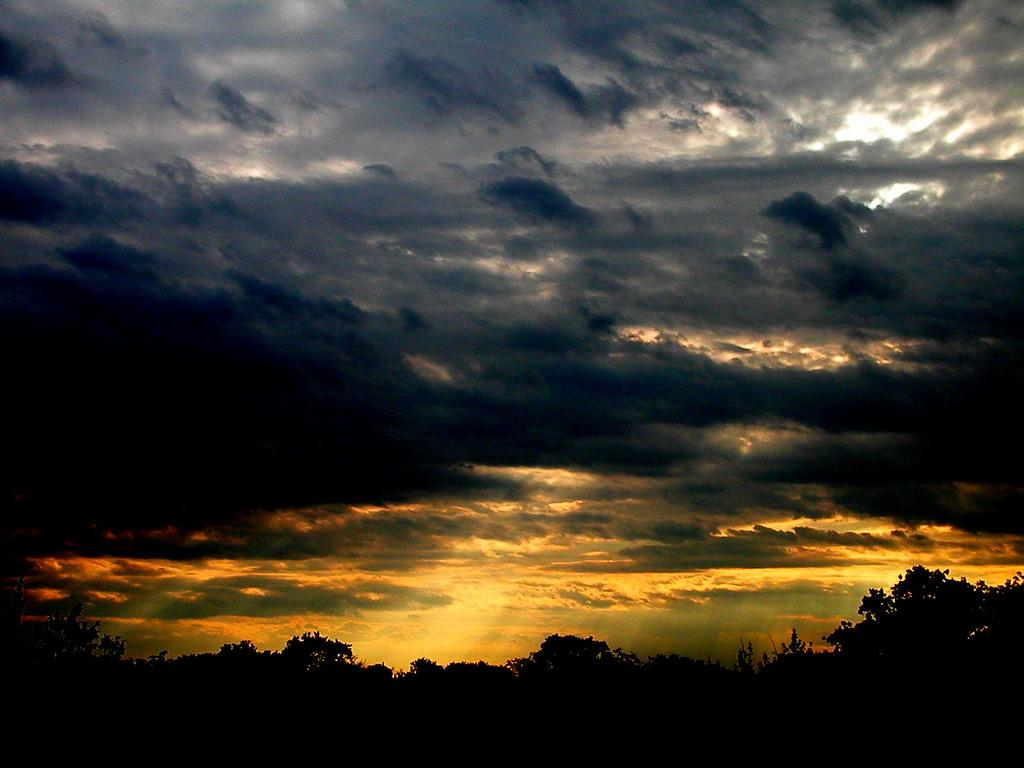What is the overall lighting condition in the image? The image is dark. What type of natural elements can be seen in the image? There are trees in the image. What part of the natural environment is visible in the image? The sky is visible in the image. How does the zephyr affect the trees in the image? There is no mention of a zephyr or any wind in the image, so we cannot determine its effect on the trees. 